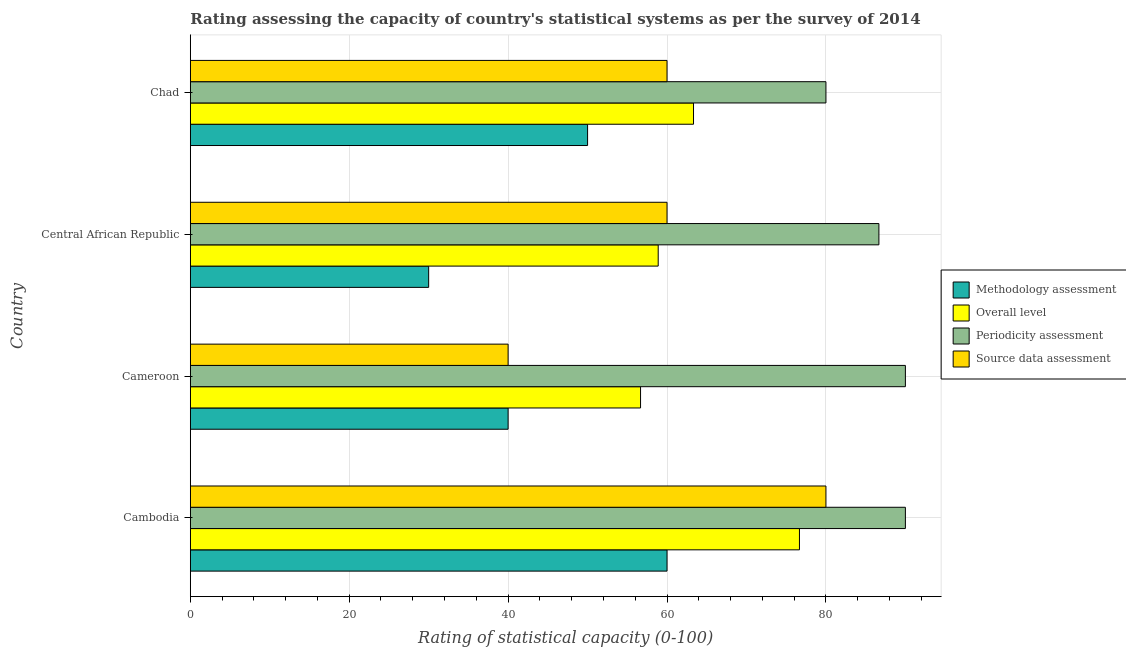How many different coloured bars are there?
Your answer should be very brief. 4. Are the number of bars per tick equal to the number of legend labels?
Your answer should be compact. Yes. How many bars are there on the 3rd tick from the top?
Your answer should be compact. 4. How many bars are there on the 2nd tick from the bottom?
Offer a very short reply. 4. What is the label of the 4th group of bars from the top?
Your answer should be compact. Cambodia. What is the overall level rating in Cambodia?
Your response must be concise. 76.67. Across all countries, what is the maximum source data assessment rating?
Provide a short and direct response. 80. Across all countries, what is the minimum source data assessment rating?
Give a very brief answer. 40. In which country was the periodicity assessment rating maximum?
Offer a very short reply. Cambodia. In which country was the periodicity assessment rating minimum?
Offer a terse response. Chad. What is the total periodicity assessment rating in the graph?
Your answer should be very brief. 346.67. What is the difference between the source data assessment rating in Cambodia and that in Chad?
Provide a short and direct response. 20. What is the difference between the source data assessment rating in Cameroon and the methodology assessment rating in Cambodia?
Keep it short and to the point. -20. What is the average overall level rating per country?
Offer a terse response. 63.89. What is the ratio of the overall level rating in Cameroon to that in Chad?
Provide a succinct answer. 0.9. Is the methodology assessment rating in Cambodia less than that in Chad?
Give a very brief answer. No. Is the difference between the overall level rating in Cambodia and Cameroon greater than the difference between the periodicity assessment rating in Cambodia and Cameroon?
Keep it short and to the point. Yes. What is the difference between the highest and the second highest periodicity assessment rating?
Give a very brief answer. 0. What is the difference between the highest and the lowest overall level rating?
Your answer should be compact. 20. Is it the case that in every country, the sum of the periodicity assessment rating and source data assessment rating is greater than the sum of methodology assessment rating and overall level rating?
Give a very brief answer. No. What does the 3rd bar from the top in Chad represents?
Give a very brief answer. Overall level. What does the 4th bar from the bottom in Cambodia represents?
Make the answer very short. Source data assessment. Is it the case that in every country, the sum of the methodology assessment rating and overall level rating is greater than the periodicity assessment rating?
Provide a short and direct response. Yes. Are the values on the major ticks of X-axis written in scientific E-notation?
Ensure brevity in your answer.  No. Where does the legend appear in the graph?
Give a very brief answer. Center right. How are the legend labels stacked?
Offer a terse response. Vertical. What is the title of the graph?
Provide a succinct answer. Rating assessing the capacity of country's statistical systems as per the survey of 2014 . Does "Taxes on exports" appear as one of the legend labels in the graph?
Ensure brevity in your answer.  No. What is the label or title of the X-axis?
Your answer should be very brief. Rating of statistical capacity (0-100). What is the Rating of statistical capacity (0-100) in Methodology assessment in Cambodia?
Make the answer very short. 60. What is the Rating of statistical capacity (0-100) of Overall level in Cambodia?
Offer a terse response. 76.67. What is the Rating of statistical capacity (0-100) in Periodicity assessment in Cambodia?
Provide a short and direct response. 90. What is the Rating of statistical capacity (0-100) in Source data assessment in Cambodia?
Provide a succinct answer. 80. What is the Rating of statistical capacity (0-100) of Overall level in Cameroon?
Provide a succinct answer. 56.67. What is the Rating of statistical capacity (0-100) in Overall level in Central African Republic?
Provide a succinct answer. 58.89. What is the Rating of statistical capacity (0-100) in Periodicity assessment in Central African Republic?
Provide a succinct answer. 86.67. What is the Rating of statistical capacity (0-100) of Source data assessment in Central African Republic?
Offer a terse response. 60. What is the Rating of statistical capacity (0-100) in Overall level in Chad?
Provide a succinct answer. 63.33. What is the Rating of statistical capacity (0-100) of Periodicity assessment in Chad?
Your answer should be very brief. 80. Across all countries, what is the maximum Rating of statistical capacity (0-100) of Methodology assessment?
Make the answer very short. 60. Across all countries, what is the maximum Rating of statistical capacity (0-100) of Overall level?
Offer a terse response. 76.67. Across all countries, what is the minimum Rating of statistical capacity (0-100) of Overall level?
Ensure brevity in your answer.  56.67. What is the total Rating of statistical capacity (0-100) of Methodology assessment in the graph?
Ensure brevity in your answer.  180. What is the total Rating of statistical capacity (0-100) of Overall level in the graph?
Ensure brevity in your answer.  255.56. What is the total Rating of statistical capacity (0-100) of Periodicity assessment in the graph?
Offer a terse response. 346.67. What is the total Rating of statistical capacity (0-100) in Source data assessment in the graph?
Provide a succinct answer. 240. What is the difference between the Rating of statistical capacity (0-100) in Overall level in Cambodia and that in Cameroon?
Provide a succinct answer. 20. What is the difference between the Rating of statistical capacity (0-100) in Periodicity assessment in Cambodia and that in Cameroon?
Offer a terse response. 0. What is the difference between the Rating of statistical capacity (0-100) in Methodology assessment in Cambodia and that in Central African Republic?
Offer a terse response. 30. What is the difference between the Rating of statistical capacity (0-100) of Overall level in Cambodia and that in Central African Republic?
Make the answer very short. 17.78. What is the difference between the Rating of statistical capacity (0-100) of Periodicity assessment in Cambodia and that in Central African Republic?
Ensure brevity in your answer.  3.33. What is the difference between the Rating of statistical capacity (0-100) of Overall level in Cambodia and that in Chad?
Make the answer very short. 13.33. What is the difference between the Rating of statistical capacity (0-100) of Periodicity assessment in Cambodia and that in Chad?
Provide a short and direct response. 10. What is the difference between the Rating of statistical capacity (0-100) in Source data assessment in Cambodia and that in Chad?
Provide a succinct answer. 20. What is the difference between the Rating of statistical capacity (0-100) in Methodology assessment in Cameroon and that in Central African Republic?
Your answer should be compact. 10. What is the difference between the Rating of statistical capacity (0-100) of Overall level in Cameroon and that in Central African Republic?
Your answer should be very brief. -2.22. What is the difference between the Rating of statistical capacity (0-100) of Source data assessment in Cameroon and that in Central African Republic?
Offer a very short reply. -20. What is the difference between the Rating of statistical capacity (0-100) in Methodology assessment in Cameroon and that in Chad?
Your answer should be very brief. -10. What is the difference between the Rating of statistical capacity (0-100) of Overall level in Cameroon and that in Chad?
Make the answer very short. -6.67. What is the difference between the Rating of statistical capacity (0-100) of Methodology assessment in Central African Republic and that in Chad?
Provide a succinct answer. -20. What is the difference between the Rating of statistical capacity (0-100) in Overall level in Central African Republic and that in Chad?
Offer a terse response. -4.44. What is the difference between the Rating of statistical capacity (0-100) of Methodology assessment in Cambodia and the Rating of statistical capacity (0-100) of Periodicity assessment in Cameroon?
Offer a very short reply. -30. What is the difference between the Rating of statistical capacity (0-100) of Methodology assessment in Cambodia and the Rating of statistical capacity (0-100) of Source data assessment in Cameroon?
Your answer should be very brief. 20. What is the difference between the Rating of statistical capacity (0-100) in Overall level in Cambodia and the Rating of statistical capacity (0-100) in Periodicity assessment in Cameroon?
Provide a succinct answer. -13.33. What is the difference between the Rating of statistical capacity (0-100) in Overall level in Cambodia and the Rating of statistical capacity (0-100) in Source data assessment in Cameroon?
Provide a succinct answer. 36.67. What is the difference between the Rating of statistical capacity (0-100) in Methodology assessment in Cambodia and the Rating of statistical capacity (0-100) in Periodicity assessment in Central African Republic?
Offer a terse response. -26.67. What is the difference between the Rating of statistical capacity (0-100) of Overall level in Cambodia and the Rating of statistical capacity (0-100) of Source data assessment in Central African Republic?
Your answer should be compact. 16.67. What is the difference between the Rating of statistical capacity (0-100) in Methodology assessment in Cambodia and the Rating of statistical capacity (0-100) in Overall level in Chad?
Your answer should be compact. -3.33. What is the difference between the Rating of statistical capacity (0-100) in Overall level in Cambodia and the Rating of statistical capacity (0-100) in Source data assessment in Chad?
Ensure brevity in your answer.  16.67. What is the difference between the Rating of statistical capacity (0-100) in Periodicity assessment in Cambodia and the Rating of statistical capacity (0-100) in Source data assessment in Chad?
Your response must be concise. 30. What is the difference between the Rating of statistical capacity (0-100) in Methodology assessment in Cameroon and the Rating of statistical capacity (0-100) in Overall level in Central African Republic?
Offer a terse response. -18.89. What is the difference between the Rating of statistical capacity (0-100) in Methodology assessment in Cameroon and the Rating of statistical capacity (0-100) in Periodicity assessment in Central African Republic?
Provide a succinct answer. -46.67. What is the difference between the Rating of statistical capacity (0-100) of Overall level in Cameroon and the Rating of statistical capacity (0-100) of Source data assessment in Central African Republic?
Your answer should be very brief. -3.33. What is the difference between the Rating of statistical capacity (0-100) of Periodicity assessment in Cameroon and the Rating of statistical capacity (0-100) of Source data assessment in Central African Republic?
Offer a terse response. 30. What is the difference between the Rating of statistical capacity (0-100) in Methodology assessment in Cameroon and the Rating of statistical capacity (0-100) in Overall level in Chad?
Your answer should be very brief. -23.33. What is the difference between the Rating of statistical capacity (0-100) in Overall level in Cameroon and the Rating of statistical capacity (0-100) in Periodicity assessment in Chad?
Provide a short and direct response. -23.33. What is the difference between the Rating of statistical capacity (0-100) of Methodology assessment in Central African Republic and the Rating of statistical capacity (0-100) of Overall level in Chad?
Provide a short and direct response. -33.33. What is the difference between the Rating of statistical capacity (0-100) of Methodology assessment in Central African Republic and the Rating of statistical capacity (0-100) of Periodicity assessment in Chad?
Keep it short and to the point. -50. What is the difference between the Rating of statistical capacity (0-100) of Overall level in Central African Republic and the Rating of statistical capacity (0-100) of Periodicity assessment in Chad?
Your answer should be compact. -21.11. What is the difference between the Rating of statistical capacity (0-100) in Overall level in Central African Republic and the Rating of statistical capacity (0-100) in Source data assessment in Chad?
Keep it short and to the point. -1.11. What is the difference between the Rating of statistical capacity (0-100) in Periodicity assessment in Central African Republic and the Rating of statistical capacity (0-100) in Source data assessment in Chad?
Provide a short and direct response. 26.67. What is the average Rating of statistical capacity (0-100) in Overall level per country?
Offer a terse response. 63.89. What is the average Rating of statistical capacity (0-100) in Periodicity assessment per country?
Provide a succinct answer. 86.67. What is the average Rating of statistical capacity (0-100) of Source data assessment per country?
Make the answer very short. 60. What is the difference between the Rating of statistical capacity (0-100) in Methodology assessment and Rating of statistical capacity (0-100) in Overall level in Cambodia?
Provide a succinct answer. -16.67. What is the difference between the Rating of statistical capacity (0-100) of Methodology assessment and Rating of statistical capacity (0-100) of Source data assessment in Cambodia?
Keep it short and to the point. -20. What is the difference between the Rating of statistical capacity (0-100) of Overall level and Rating of statistical capacity (0-100) of Periodicity assessment in Cambodia?
Your answer should be compact. -13.33. What is the difference between the Rating of statistical capacity (0-100) of Overall level and Rating of statistical capacity (0-100) of Source data assessment in Cambodia?
Your answer should be very brief. -3.33. What is the difference between the Rating of statistical capacity (0-100) of Periodicity assessment and Rating of statistical capacity (0-100) of Source data assessment in Cambodia?
Your answer should be very brief. 10. What is the difference between the Rating of statistical capacity (0-100) of Methodology assessment and Rating of statistical capacity (0-100) of Overall level in Cameroon?
Give a very brief answer. -16.67. What is the difference between the Rating of statistical capacity (0-100) in Methodology assessment and Rating of statistical capacity (0-100) in Periodicity assessment in Cameroon?
Offer a terse response. -50. What is the difference between the Rating of statistical capacity (0-100) in Methodology assessment and Rating of statistical capacity (0-100) in Source data assessment in Cameroon?
Give a very brief answer. 0. What is the difference between the Rating of statistical capacity (0-100) in Overall level and Rating of statistical capacity (0-100) in Periodicity assessment in Cameroon?
Ensure brevity in your answer.  -33.33. What is the difference between the Rating of statistical capacity (0-100) in Overall level and Rating of statistical capacity (0-100) in Source data assessment in Cameroon?
Make the answer very short. 16.67. What is the difference between the Rating of statistical capacity (0-100) in Periodicity assessment and Rating of statistical capacity (0-100) in Source data assessment in Cameroon?
Keep it short and to the point. 50. What is the difference between the Rating of statistical capacity (0-100) of Methodology assessment and Rating of statistical capacity (0-100) of Overall level in Central African Republic?
Keep it short and to the point. -28.89. What is the difference between the Rating of statistical capacity (0-100) of Methodology assessment and Rating of statistical capacity (0-100) of Periodicity assessment in Central African Republic?
Provide a short and direct response. -56.67. What is the difference between the Rating of statistical capacity (0-100) in Overall level and Rating of statistical capacity (0-100) in Periodicity assessment in Central African Republic?
Give a very brief answer. -27.78. What is the difference between the Rating of statistical capacity (0-100) of Overall level and Rating of statistical capacity (0-100) of Source data assessment in Central African Republic?
Ensure brevity in your answer.  -1.11. What is the difference between the Rating of statistical capacity (0-100) in Periodicity assessment and Rating of statistical capacity (0-100) in Source data assessment in Central African Republic?
Provide a succinct answer. 26.67. What is the difference between the Rating of statistical capacity (0-100) of Methodology assessment and Rating of statistical capacity (0-100) of Overall level in Chad?
Keep it short and to the point. -13.33. What is the difference between the Rating of statistical capacity (0-100) in Overall level and Rating of statistical capacity (0-100) in Periodicity assessment in Chad?
Provide a succinct answer. -16.67. What is the difference between the Rating of statistical capacity (0-100) of Overall level and Rating of statistical capacity (0-100) of Source data assessment in Chad?
Provide a short and direct response. 3.33. What is the difference between the Rating of statistical capacity (0-100) of Periodicity assessment and Rating of statistical capacity (0-100) of Source data assessment in Chad?
Provide a succinct answer. 20. What is the ratio of the Rating of statistical capacity (0-100) in Methodology assessment in Cambodia to that in Cameroon?
Ensure brevity in your answer.  1.5. What is the ratio of the Rating of statistical capacity (0-100) in Overall level in Cambodia to that in Cameroon?
Provide a short and direct response. 1.35. What is the ratio of the Rating of statistical capacity (0-100) in Periodicity assessment in Cambodia to that in Cameroon?
Offer a terse response. 1. What is the ratio of the Rating of statistical capacity (0-100) in Source data assessment in Cambodia to that in Cameroon?
Offer a very short reply. 2. What is the ratio of the Rating of statistical capacity (0-100) in Methodology assessment in Cambodia to that in Central African Republic?
Your answer should be compact. 2. What is the ratio of the Rating of statistical capacity (0-100) of Overall level in Cambodia to that in Central African Republic?
Your answer should be very brief. 1.3. What is the ratio of the Rating of statistical capacity (0-100) in Source data assessment in Cambodia to that in Central African Republic?
Your response must be concise. 1.33. What is the ratio of the Rating of statistical capacity (0-100) of Overall level in Cambodia to that in Chad?
Give a very brief answer. 1.21. What is the ratio of the Rating of statistical capacity (0-100) in Periodicity assessment in Cambodia to that in Chad?
Ensure brevity in your answer.  1.12. What is the ratio of the Rating of statistical capacity (0-100) in Overall level in Cameroon to that in Central African Republic?
Your answer should be very brief. 0.96. What is the ratio of the Rating of statistical capacity (0-100) in Periodicity assessment in Cameroon to that in Central African Republic?
Give a very brief answer. 1.04. What is the ratio of the Rating of statistical capacity (0-100) in Methodology assessment in Cameroon to that in Chad?
Offer a terse response. 0.8. What is the ratio of the Rating of statistical capacity (0-100) in Overall level in Cameroon to that in Chad?
Provide a short and direct response. 0.89. What is the ratio of the Rating of statistical capacity (0-100) in Source data assessment in Cameroon to that in Chad?
Keep it short and to the point. 0.67. What is the ratio of the Rating of statistical capacity (0-100) in Methodology assessment in Central African Republic to that in Chad?
Your response must be concise. 0.6. What is the ratio of the Rating of statistical capacity (0-100) of Overall level in Central African Republic to that in Chad?
Your answer should be compact. 0.93. What is the difference between the highest and the second highest Rating of statistical capacity (0-100) in Overall level?
Your answer should be very brief. 13.33. What is the difference between the highest and the second highest Rating of statistical capacity (0-100) in Periodicity assessment?
Provide a short and direct response. 0. What is the difference between the highest and the second highest Rating of statistical capacity (0-100) of Source data assessment?
Offer a very short reply. 20. What is the difference between the highest and the lowest Rating of statistical capacity (0-100) of Periodicity assessment?
Your answer should be very brief. 10. What is the difference between the highest and the lowest Rating of statistical capacity (0-100) of Source data assessment?
Give a very brief answer. 40. 